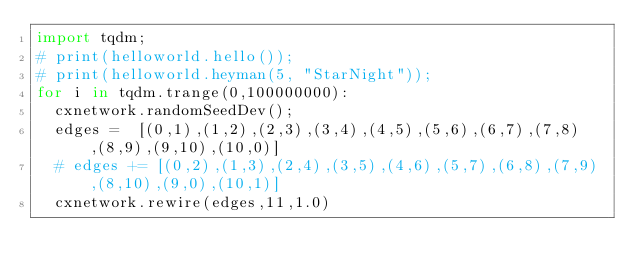Convert code to text. <code><loc_0><loc_0><loc_500><loc_500><_Python_>import tqdm;
# print(helloworld.hello());
# print(helloworld.heyman(5, "StarNight"));
for i in tqdm.trange(0,100000000):
	cxnetwork.randomSeedDev();
	edges =  [(0,1),(1,2),(2,3),(3,4),(4,5),(5,6),(6,7),(7,8),(8,9),(9,10),(10,0)]
	# edges += [(0,2),(1,3),(2,4),(3,5),(4,6),(5,7),(6,8),(7,9),(8,10),(9,0),(10,1)]
	cxnetwork.rewire(edges,11,1.0)
</code> 